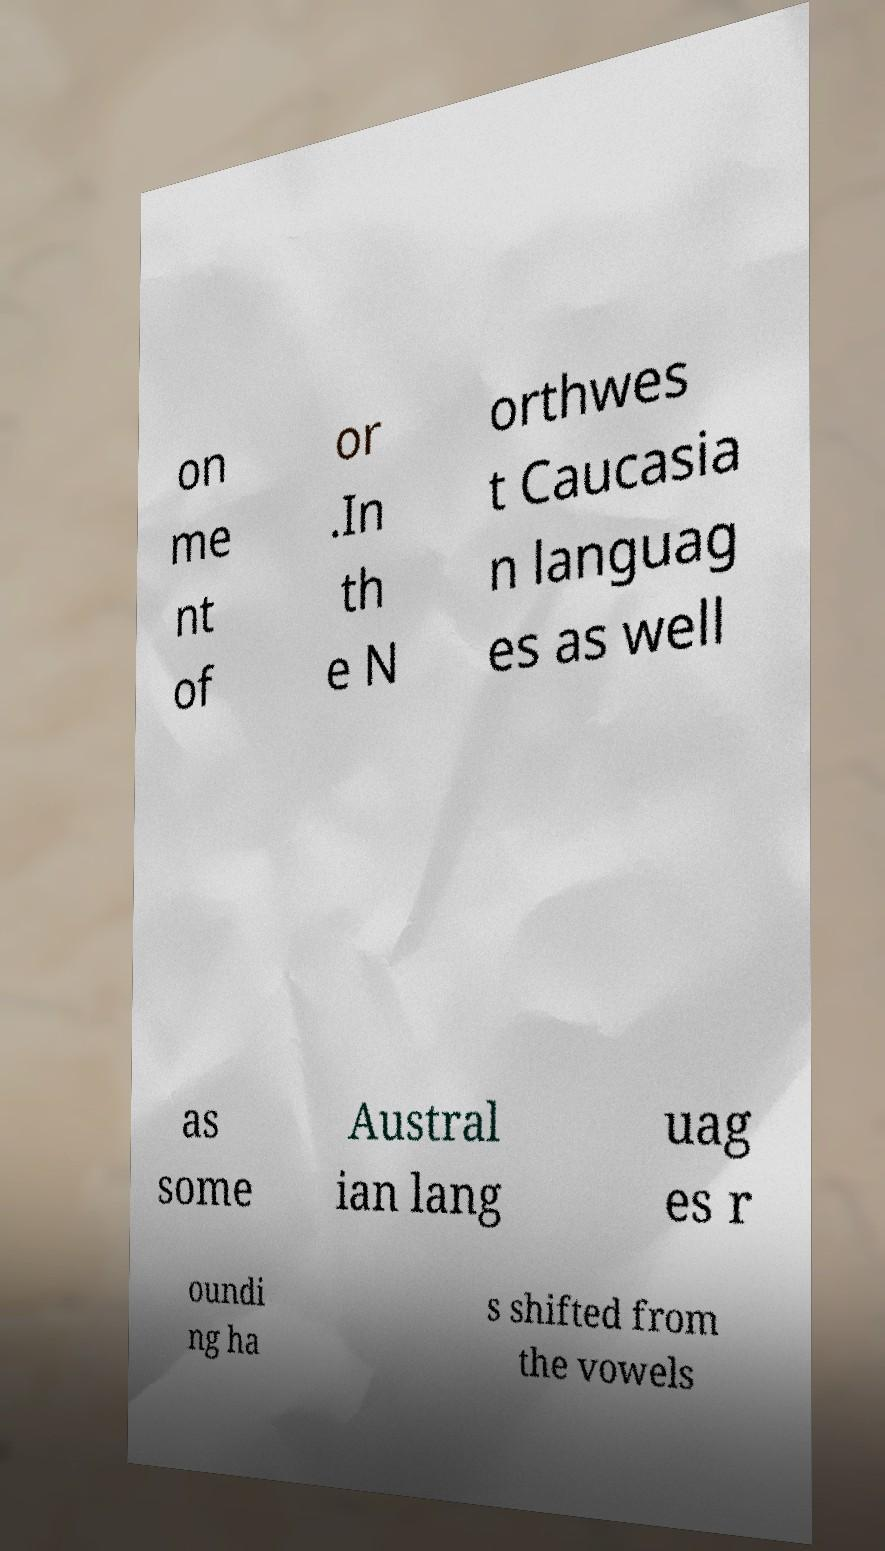Can you accurately transcribe the text from the provided image for me? on me nt of or .In th e N orthwes t Caucasia n languag es as well as some Austral ian lang uag es r oundi ng ha s shifted from the vowels 